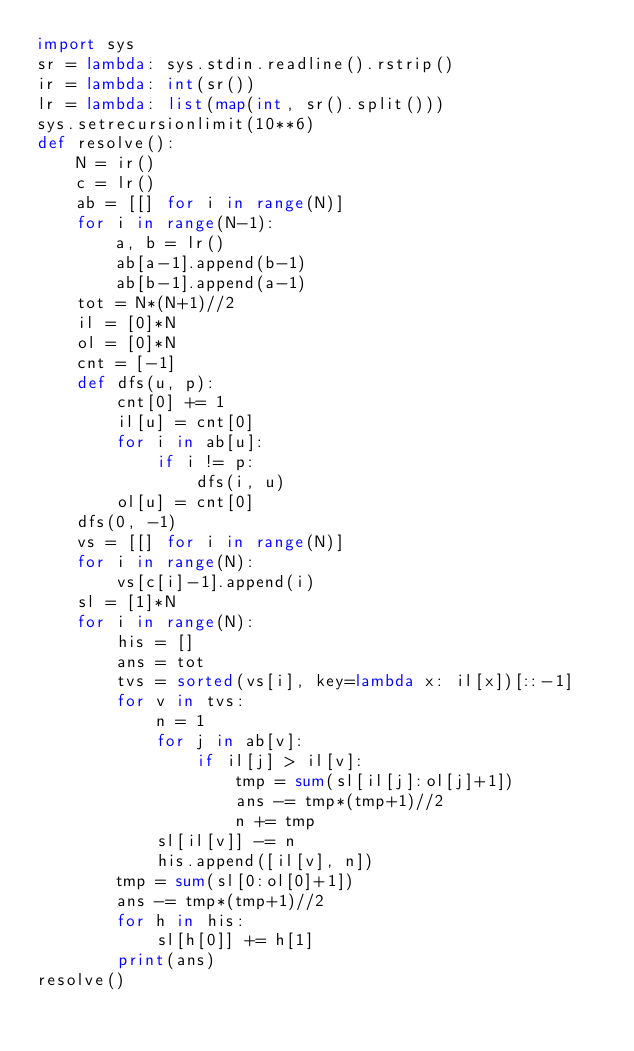<code> <loc_0><loc_0><loc_500><loc_500><_Python_>import sys
sr = lambda: sys.stdin.readline().rstrip()
ir = lambda: int(sr())
lr = lambda: list(map(int, sr().split()))
sys.setrecursionlimit(10**6)
def resolve():
    N = ir()
    c = lr()
    ab = [[] for i in range(N)]
    for i in range(N-1):
        a, b = lr()
        ab[a-1].append(b-1)
        ab[b-1].append(a-1)
    tot = N*(N+1)//2
    il = [0]*N
    ol = [0]*N
    cnt = [-1]
    def dfs(u, p):
        cnt[0] += 1
        il[u] = cnt[0]
        for i in ab[u]:
            if i != p:
                dfs(i, u)
        ol[u] = cnt[0]
    dfs(0, -1)
    vs = [[] for i in range(N)]
    for i in range(N):
        vs[c[i]-1].append(i)
    sl = [1]*N
    for i in range(N):
        his = []
        ans = tot
        tvs = sorted(vs[i], key=lambda x: il[x])[::-1]
        for v in tvs:
            n = 1
            for j in ab[v]:
                if il[j] > il[v]:
                    tmp = sum(sl[il[j]:ol[j]+1])
                    ans -= tmp*(tmp+1)//2
                    n += tmp
            sl[il[v]] -= n
            his.append([il[v], n])
        tmp = sum(sl[0:ol[0]+1])
        ans -= tmp*(tmp+1)//2
        for h in his:
            sl[h[0]] += h[1]
        print(ans)
resolve()</code> 